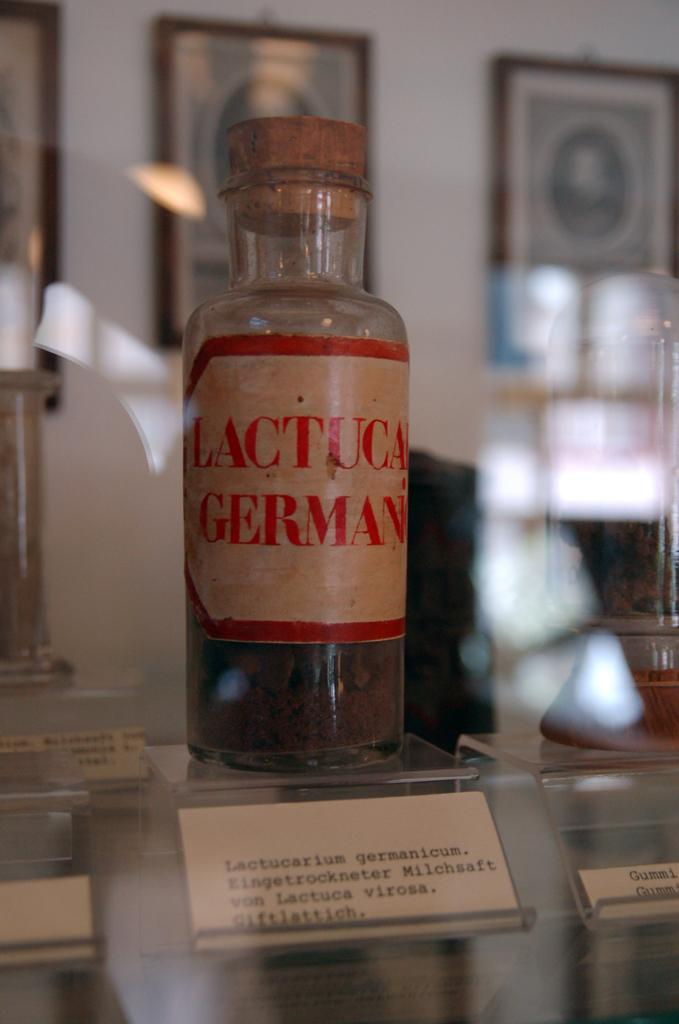<image>
Summarize the visual content of the image. Bottle of Lactuca german with a red and white label. 